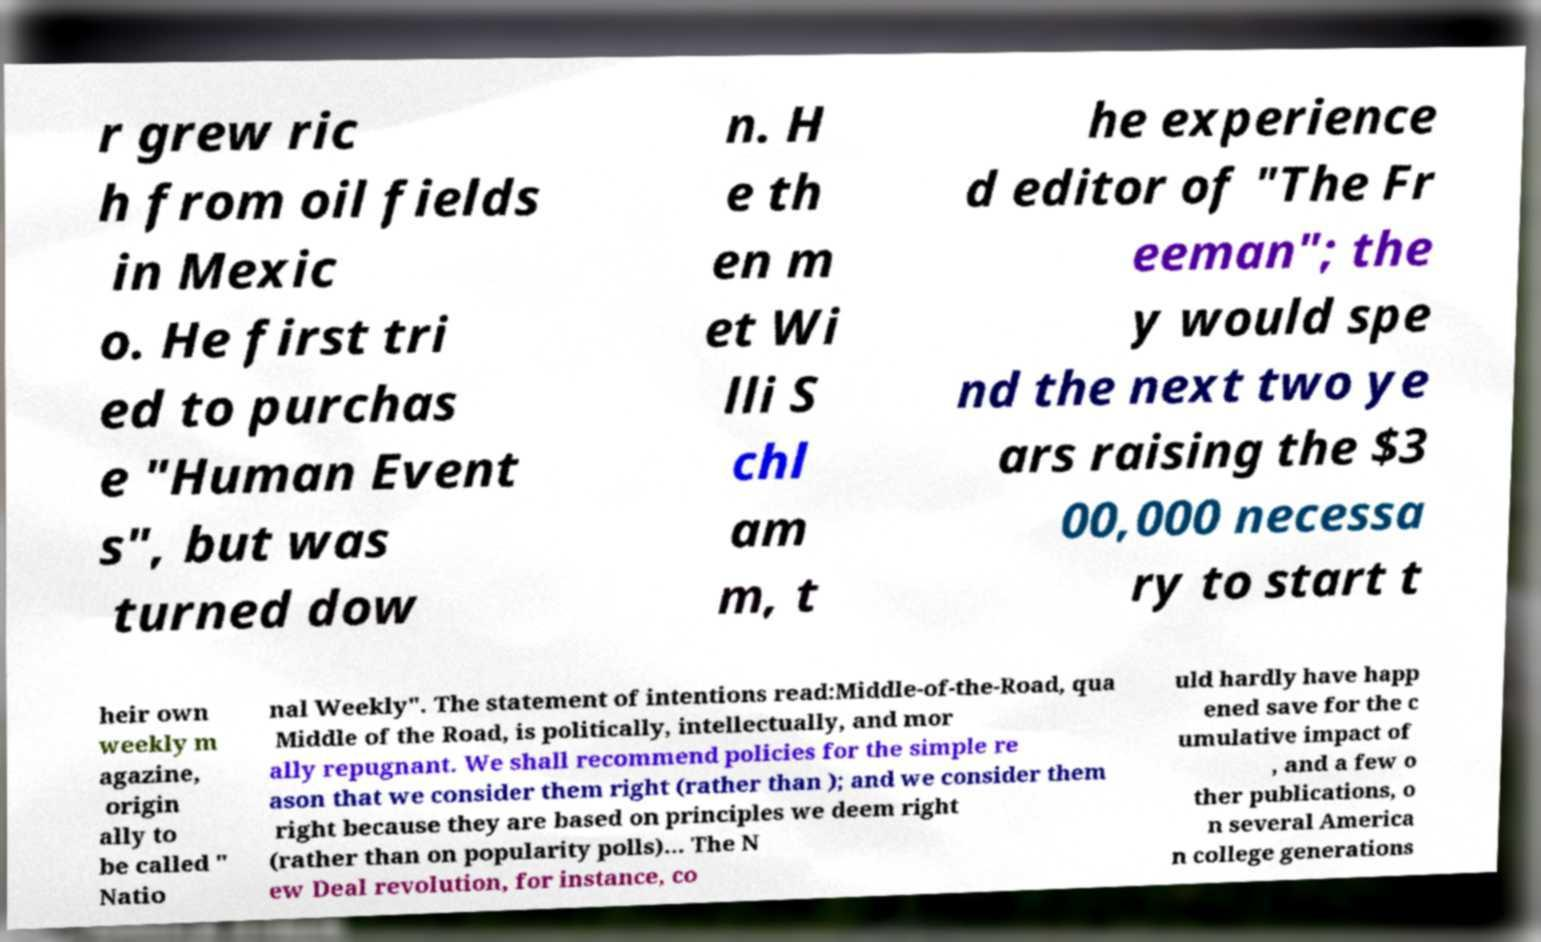What messages or text are displayed in this image? I need them in a readable, typed format. r grew ric h from oil fields in Mexic o. He first tri ed to purchas e "Human Event s", but was turned dow n. H e th en m et Wi lli S chl am m, t he experience d editor of "The Fr eeman"; the y would spe nd the next two ye ars raising the $3 00,000 necessa ry to start t heir own weekly m agazine, origin ally to be called " Natio nal Weekly". The statement of intentions read:Middle-of-the-Road, qua Middle of the Road, is politically, intellectually, and mor ally repugnant. We shall recommend policies for the simple re ason that we consider them right (rather than ); and we consider them right because they are based on principles we deem right (rather than on popularity polls)... The N ew Deal revolution, for instance, co uld hardly have happ ened save for the c umulative impact of , and a few o ther publications, o n several America n college generations 